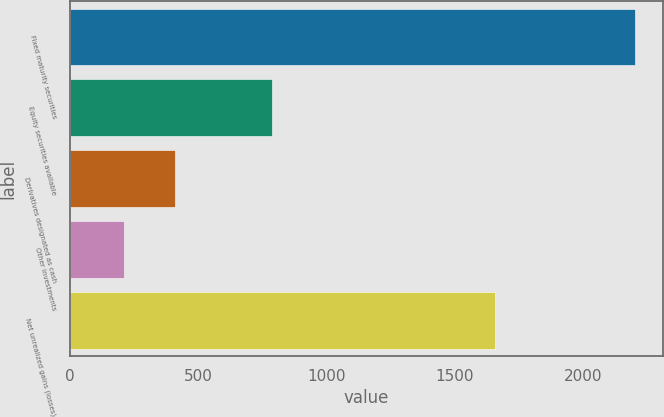<chart> <loc_0><loc_0><loc_500><loc_500><bar_chart><fcel>Fixed maturity securities<fcel>Equity securities available<fcel>Derivatives designated as cash<fcel>Other investments<fcel>Net unrealized gains (losses)<nl><fcel>2203<fcel>789<fcel>409.3<fcel>210<fcel>1656<nl></chart> 